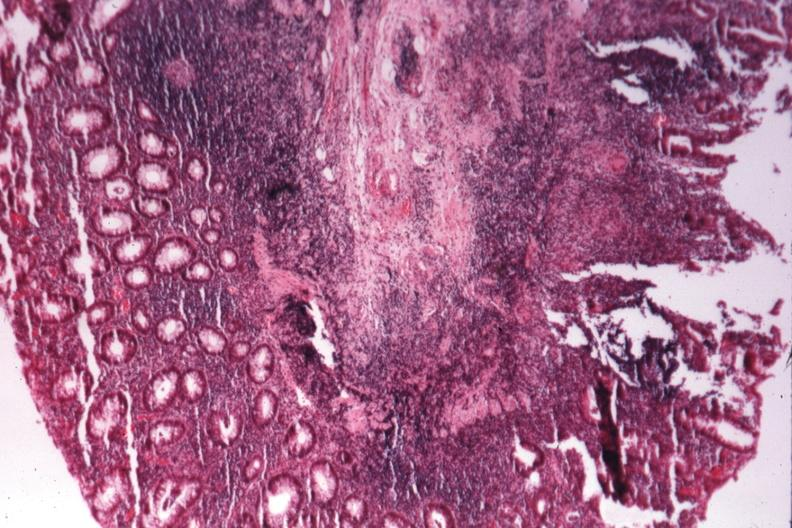where is this from?
Answer the question using a single word or phrase. Gastrointestinal system 